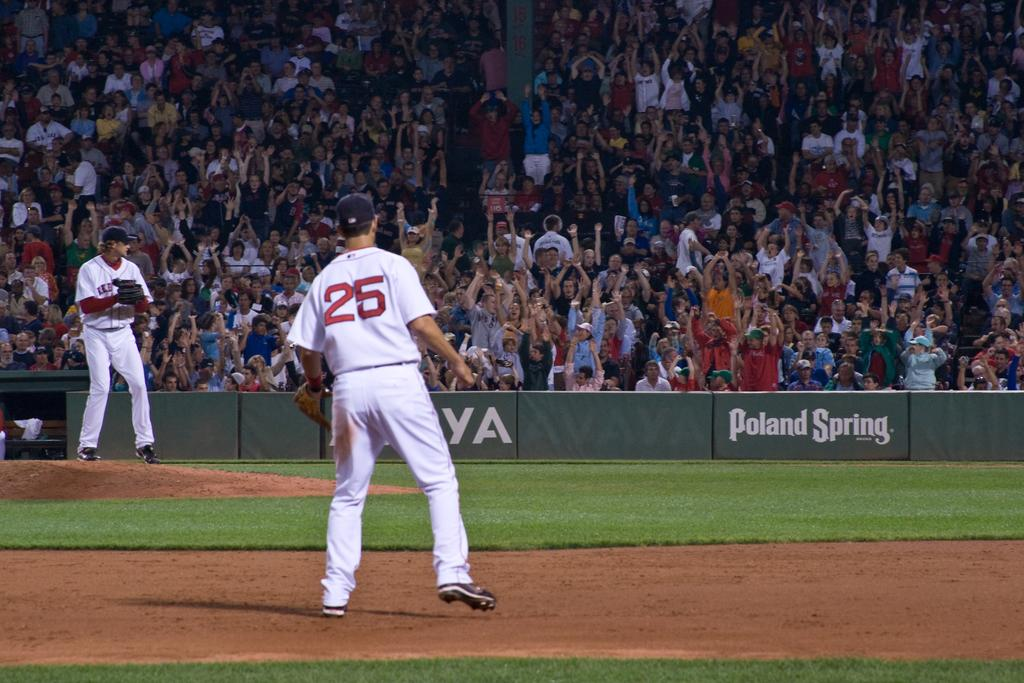Provide a one-sentence caption for the provided image. number 25 baseball player on a field sponsored by poland spring. 